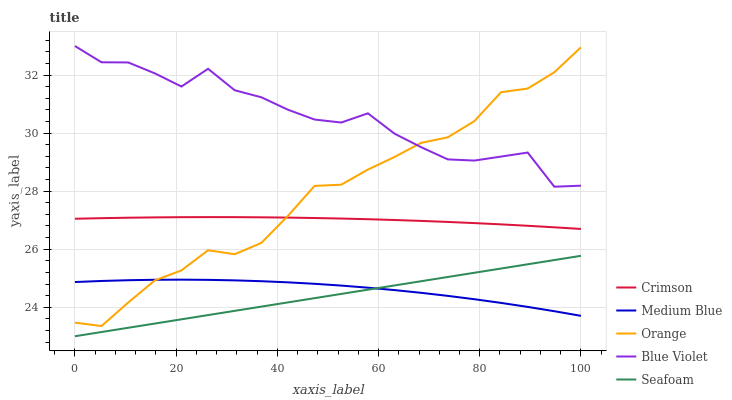Does Seafoam have the minimum area under the curve?
Answer yes or no. Yes. Does Blue Violet have the maximum area under the curve?
Answer yes or no. Yes. Does Orange have the minimum area under the curve?
Answer yes or no. No. Does Orange have the maximum area under the curve?
Answer yes or no. No. Is Seafoam the smoothest?
Answer yes or no. Yes. Is Blue Violet the roughest?
Answer yes or no. Yes. Is Orange the smoothest?
Answer yes or no. No. Is Orange the roughest?
Answer yes or no. No. Does Seafoam have the lowest value?
Answer yes or no. Yes. Does Orange have the lowest value?
Answer yes or no. No. Does Blue Violet have the highest value?
Answer yes or no. Yes. Does Orange have the highest value?
Answer yes or no. No. Is Seafoam less than Blue Violet?
Answer yes or no. Yes. Is Blue Violet greater than Medium Blue?
Answer yes or no. Yes. Does Orange intersect Crimson?
Answer yes or no. Yes. Is Orange less than Crimson?
Answer yes or no. No. Is Orange greater than Crimson?
Answer yes or no. No. Does Seafoam intersect Blue Violet?
Answer yes or no. No. 